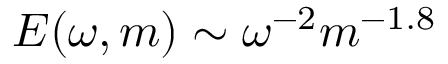Convert formula to latex. <formula><loc_0><loc_0><loc_500><loc_500>E ( \omega , m ) \sim \omega ^ { - 2 } m ^ { - 1 . 8 }</formula> 